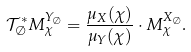<formula> <loc_0><loc_0><loc_500><loc_500>\mathcal { T } _ { \emptyset } ^ { * } M _ { \chi } ^ { Y _ { \emptyset } } = \frac { \mu _ { X } ( \chi ) } { \mu _ { Y } ( \chi ) } \cdot M _ { \chi } ^ { X _ { \emptyset } } .</formula> 